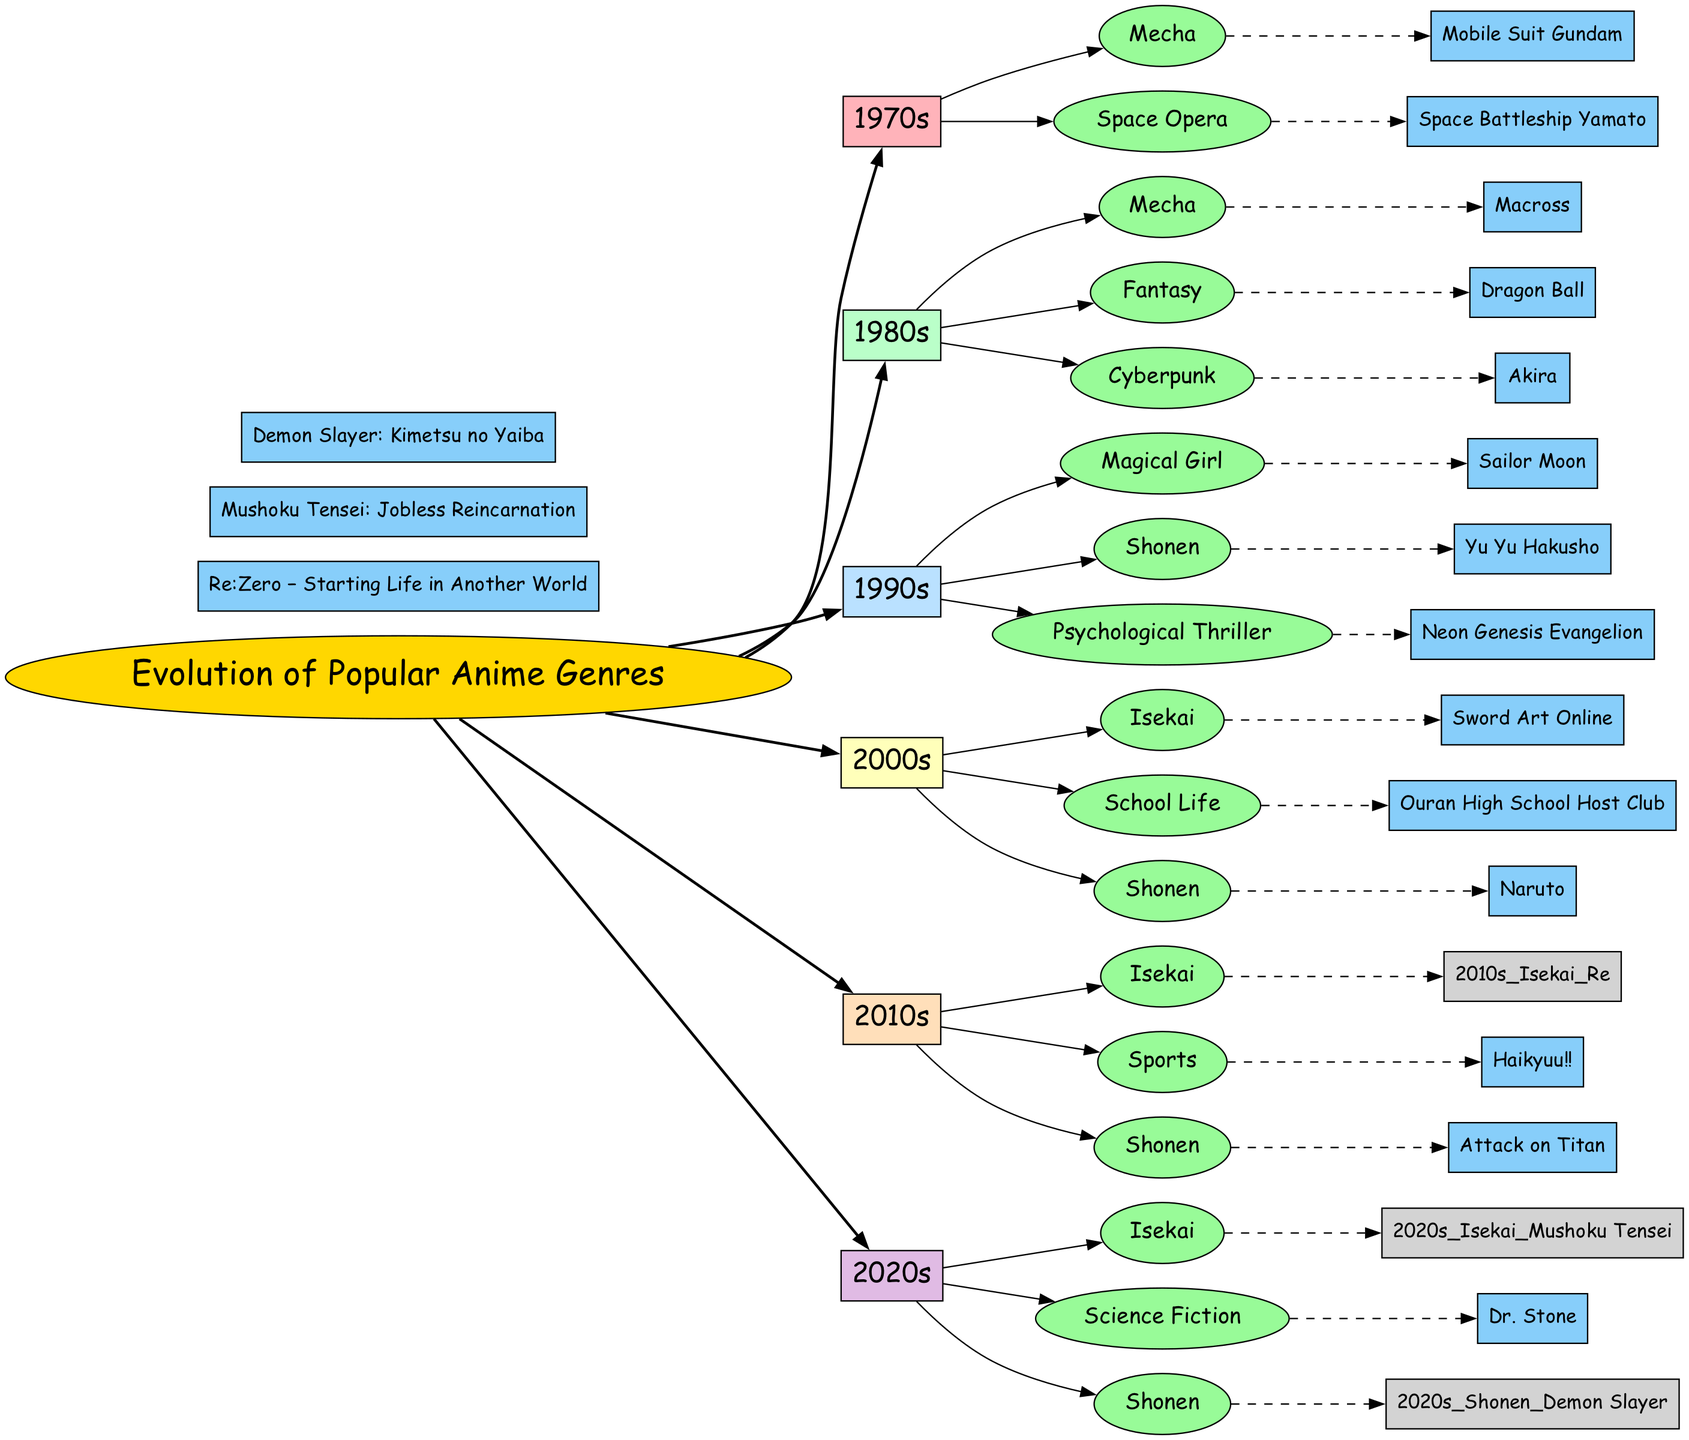What genres are present in the 1980s? To find the genres in the 1980s, I look at the 1980s node and see the genres listed under it: Mecha, Fantasy, and Cyberpunk.
Answer: Mecha, Fantasy, Cyberpunk How many anime genres are listed for the 1990s? In the 1990s node, I identify the genres listed: Magical Girl, Shonen, and Psychological Thriller. Counting these genres gives me a total of three.
Answer: 3 Which anime is an example of the Mecha genre from the 1970s? I look at the Mecha genre node under the 1970s section. The example listed under it is Mobile Suit Gundam.
Answer: Mobile Suit Gundam What is the latest genre of anime mentioned in the diagram? Reviewing the last decade, the 2020s, I identify the genres listed, which include Isekai, Science Fiction, and Shonen. The most recent genre mentioned is Isekai.
Answer: Isekai Which decade has the example "Attack on Titan"? I locate the example "Attack on Titan" in the Shonen genre under the 2010s node. This links the anime to the decade it is associated with.
Answer: 2010s How are the genres connected to the decades in the diagram? Each genre is connected to its respective decade node with a directed edge. This shows that the genres listed belong to the timeframe they are placed under.
Answer: Directed edges What is the color used for the title node? The title node is colored gold, as indicated by the fillcolor property specified when it was created.
Answer: Gold In which decade did the genre "Sports" become popular? Looking at the 2010s decade, I notice that "Sports" is listed among the genres, indicating it became popular during this time.
Answer: 2010s What is the primary genre present in almost every decade? By examining the given decades, I see that Shonen appears in the 1990s, 2000s, 2010s, and 2020s. This indicates that Shonen is consistently popular across these decades.
Answer: Shonen 